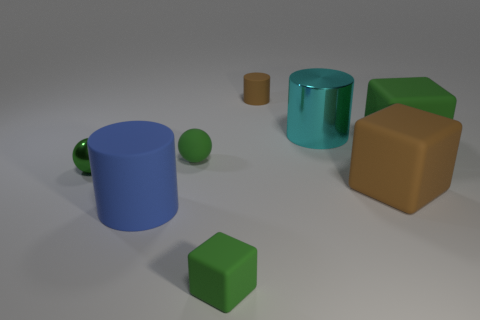Add 1 tiny balls. How many objects exist? 9 Subtract all cubes. How many objects are left? 5 Add 3 brown matte things. How many brown matte things are left? 5 Add 3 blue matte things. How many blue matte things exist? 4 Subtract 0 gray cylinders. How many objects are left? 8 Subtract all cyan shiny objects. Subtract all green blocks. How many objects are left? 5 